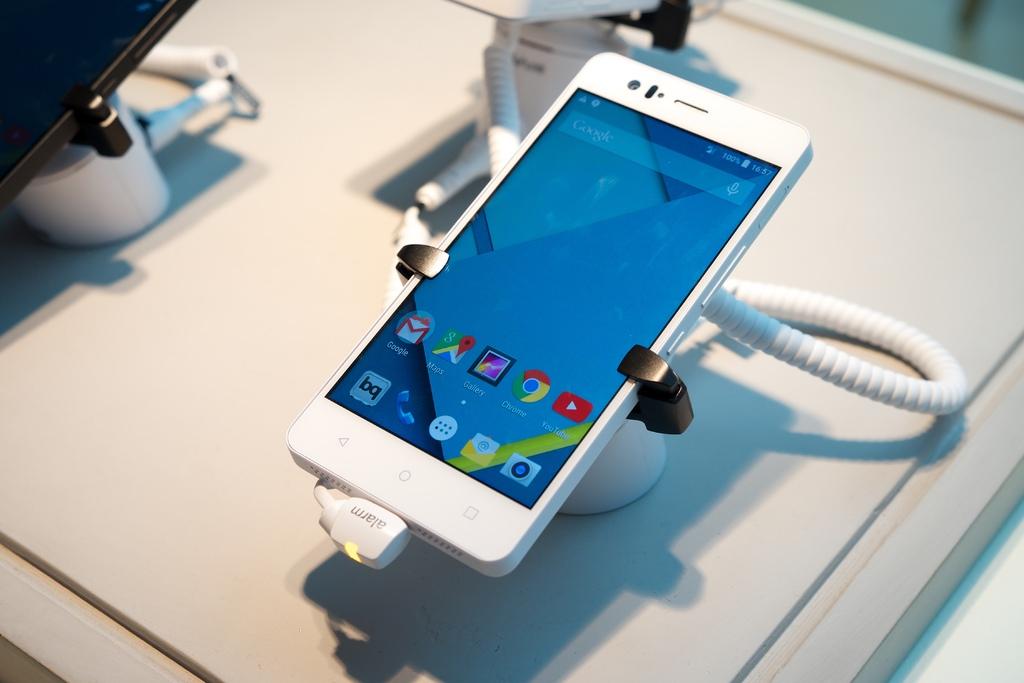What search engine is visible at the top of this phone's display?
Your answer should be compact. Google. Does the phone has google chrome?
Ensure brevity in your answer.  Yes. 